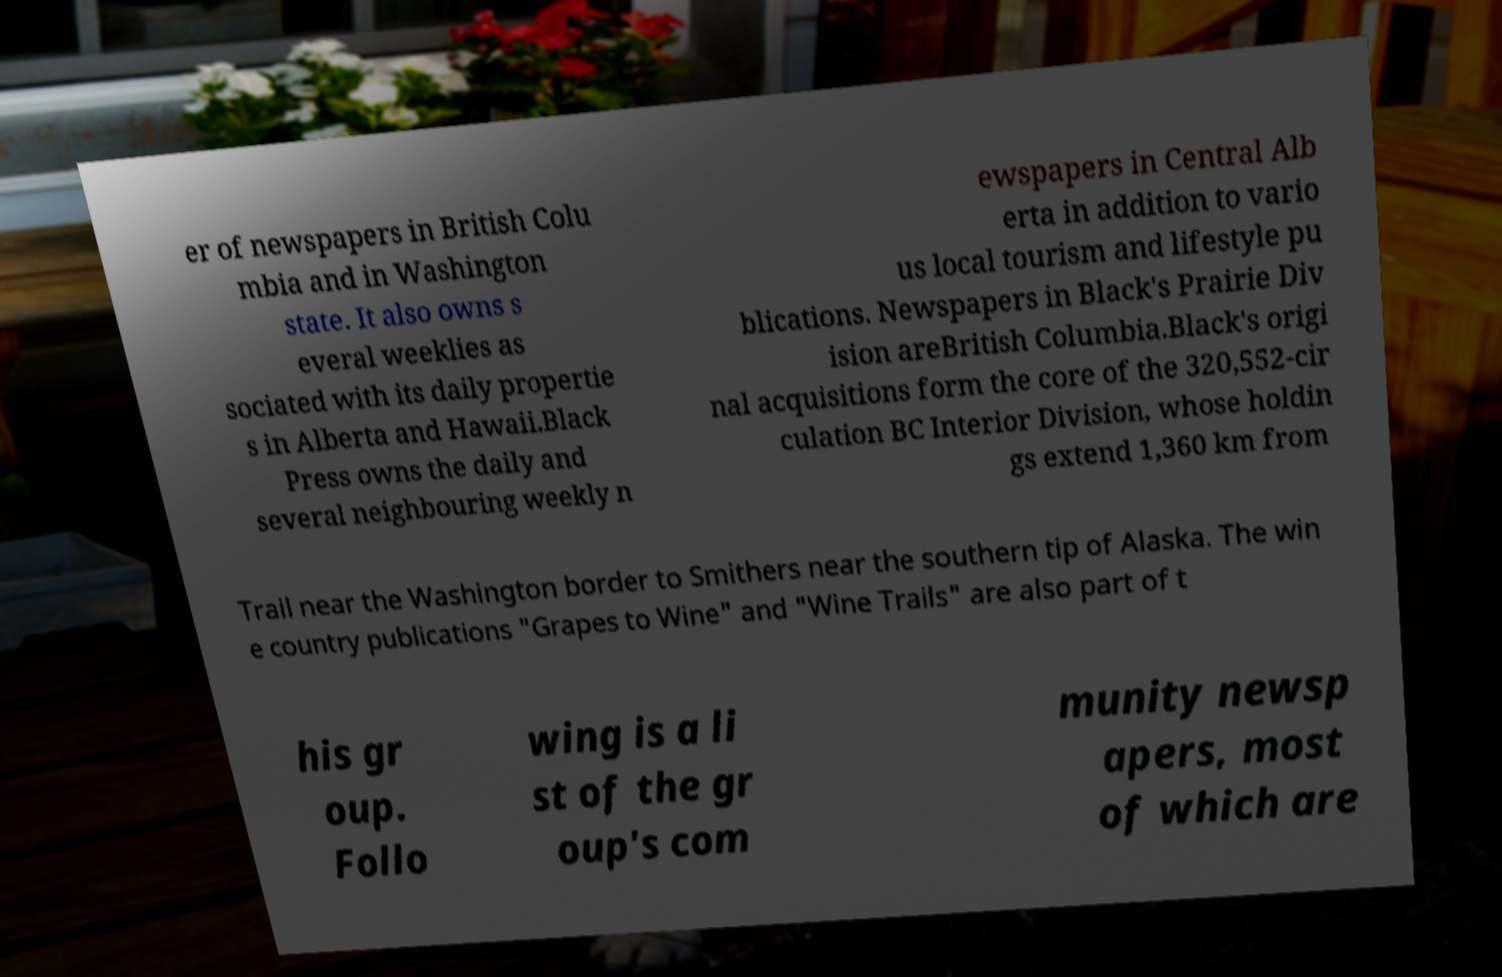I need the written content from this picture converted into text. Can you do that? er of newspapers in British Colu mbia and in Washington state. It also owns s everal weeklies as sociated with its daily propertie s in Alberta and Hawaii.Black Press owns the daily and several neighbouring weekly n ewspapers in Central Alb erta in addition to vario us local tourism and lifestyle pu blications. Newspapers in Black's Prairie Div ision areBritish Columbia.Black's origi nal acquisitions form the core of the 320,552-cir culation BC Interior Division, whose holdin gs extend 1,360 km from Trail near the Washington border to Smithers near the southern tip of Alaska. The win e country publications "Grapes to Wine" and "Wine Trails" are also part of t his gr oup. Follo wing is a li st of the gr oup's com munity newsp apers, most of which are 